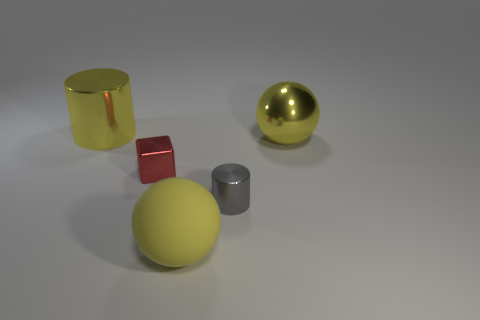How many balls are there?
Provide a short and direct response. 2. Are there more cylinders that are in front of the tiny cube than blue objects?
Offer a terse response. Yes. What is the material of the cylinder that is to the right of the small red metallic thing?
Make the answer very short. Metal. There is a big shiny object that is the same shape as the big yellow rubber object; what color is it?
Ensure brevity in your answer.  Yellow. How many cylinders have the same color as the large shiny sphere?
Provide a succinct answer. 1. Is the size of the sphere in front of the yellow shiny sphere the same as the cube that is left of the big yellow matte object?
Your answer should be compact. No. Is the size of the red shiny block the same as the cylinder in front of the yellow shiny cylinder?
Provide a succinct answer. Yes. The cube is what size?
Your answer should be compact. Small. The small cube that is made of the same material as the gray cylinder is what color?
Offer a very short reply. Red. How many large cyan things have the same material as the yellow cylinder?
Your answer should be compact. 0. 